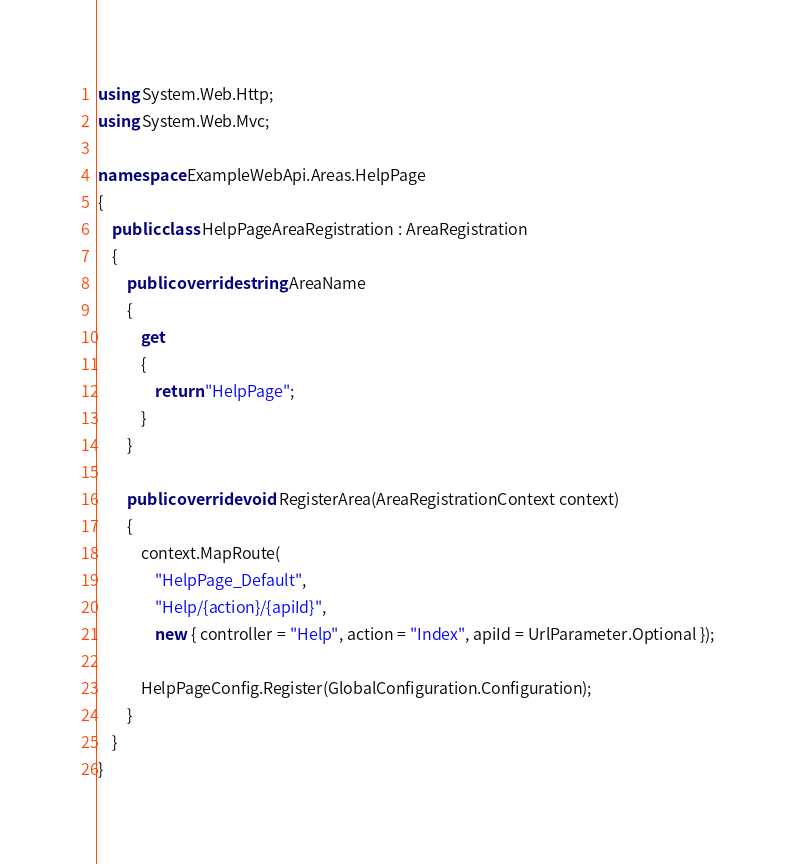Convert code to text. <code><loc_0><loc_0><loc_500><loc_500><_C#_>using System.Web.Http;
using System.Web.Mvc;

namespace ExampleWebApi.Areas.HelpPage
{
    public class HelpPageAreaRegistration : AreaRegistration
    {
        public override string AreaName
        {
            get
            {
                return "HelpPage";
            }
        }

        public override void RegisterArea(AreaRegistrationContext context)
        {
            context.MapRoute(
                "HelpPage_Default",
                "Help/{action}/{apiId}",
                new { controller = "Help", action = "Index", apiId = UrlParameter.Optional });

            HelpPageConfig.Register(GlobalConfiguration.Configuration);
        }
    }
}</code> 